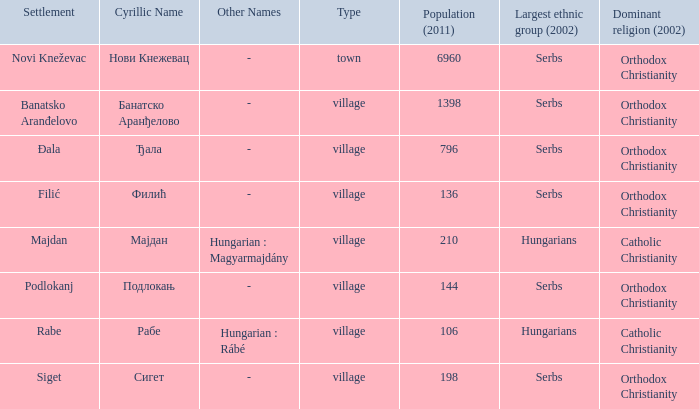What is the cyrillic and other name of rabe? Рабе ( Hungarian : Rábé ). 